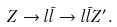Convert formula to latex. <formula><loc_0><loc_0><loc_500><loc_500>Z \rightarrow l \bar { l } \rightarrow l \bar { l } Z ^ { \prime } .</formula> 